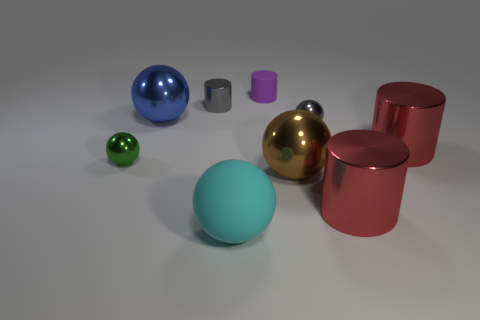How many objects are there in total, and do they have different finishes? There are a total of seven objects in the image, each with a reflective metallic finish. They come in various colors and include a mix of matte and glossy textures. 